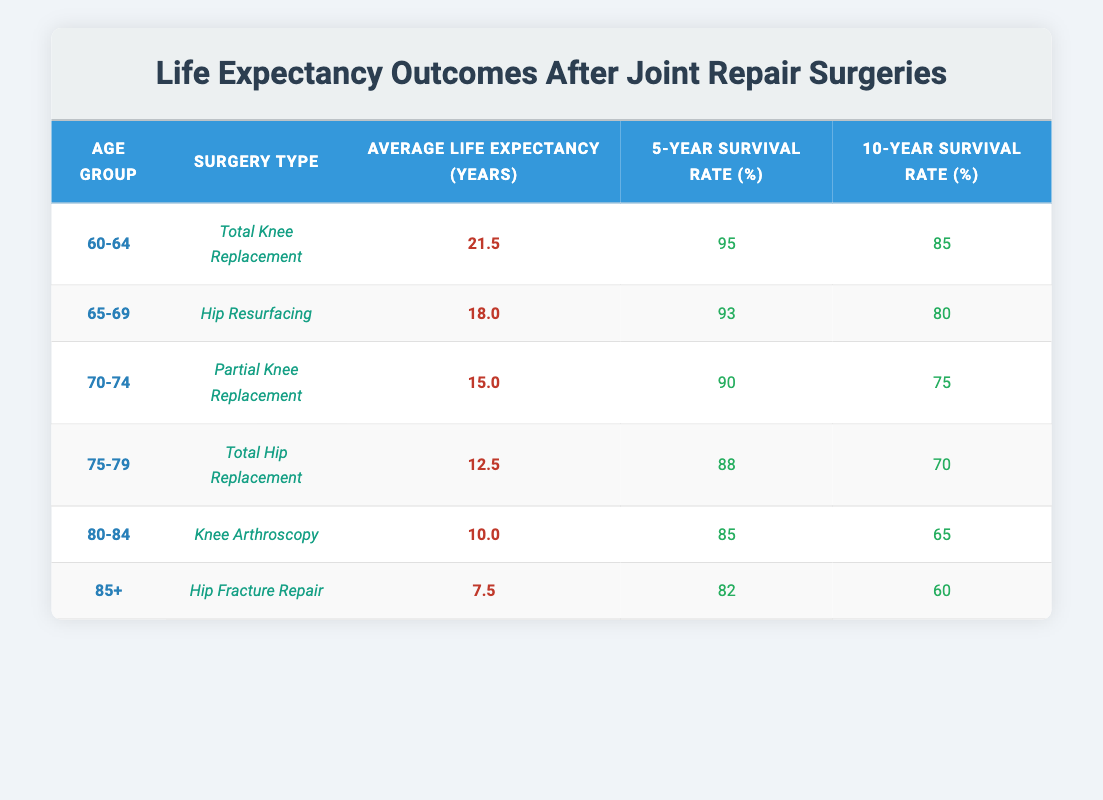What is the average life expectancy after a Total Knee Replacement for the age group 60-64? The table shows that for the age group 60-64 undergoing Total Knee Replacement, the average life expectancy post-surgery is listed as 21.5 years.
Answer: 21.5 Which surgery type has the highest 5-year survival rate? By examining the 5-year survival rates for all surgery types, Total Knee Replacement has the highest rate at 95%.
Answer: Total Knee Replacement What is the difference in average life expectancy between patients aged 70-74 and those aged 75-79? The average life expectancy for the 70-74 age group is 15.0 years, while for the 75-79 age group it is 12.5 years. The difference is 15.0 - 12.5 = 2.5 years.
Answer: 2.5 Is the 10-year survival rate for Hip Resurfacing surgery greater than 70%? The table states that the 10-year survival rate for Hip Resurfacing is 80%. As 80% is greater than 70%, the statement is true.
Answer: Yes Considering all age groups, what is the average life expectancy after surgeries? The average can be calculated by summing the average life expectancies for all age groups (21.5 + 18.0 + 15.0 + 12.5 + 10.0 + 7.5 = 84.5 years) and dividing by the number of groups (6). The average life expectancy is 84.5 / 6 = 14.08 years.
Answer: 14.08 What is the surgery type associated with the lowest average life expectancy? By examining the average life expectancy values, Hip Fracture Repair for the age group 85+ has the lowest average life expectancy at 7.5 years.
Answer: Hip Fracture Repair Does the average life expectancy increase or decrease as age groups increase? Observing the table, the average life expectancy decreases as the age groups increase. The average for 60-64 is 21.5, and for 85+, it is 7.5.
Answer: Decrease What is the 5-year survival rate for the age group 80-84 with Knee Arthroscopy? The table specifies that the 5-year survival rate for patients aged 80-84 who had Knee Arthroscopy is 85%.
Answer: 85 